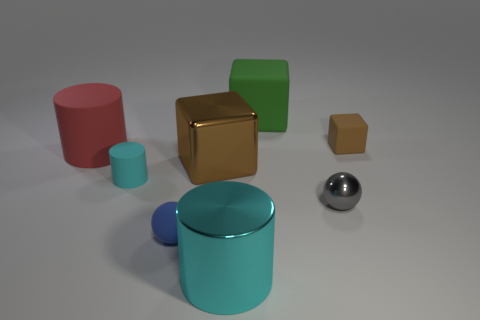Is the color of the thing that is in front of the tiny blue sphere the same as the cube that is behind the small brown cube?
Your answer should be very brief. No. What number of other objects are there of the same color as the metal sphere?
Provide a succinct answer. 0. What is the shape of the big rubber thing that is behind the small brown block?
Offer a terse response. Cube. Are there fewer small blue matte objects than large green metallic things?
Make the answer very short. No. Is the material of the ball to the right of the green thing the same as the blue object?
Make the answer very short. No. Are there any other things that are the same size as the red cylinder?
Offer a terse response. Yes. Are there any red matte cylinders on the left side of the big red matte object?
Your answer should be very brief. No. There is a large matte object that is in front of the brown thing to the right of the brown block in front of the brown rubber object; what color is it?
Give a very brief answer. Red. There is a brown metal object that is the same size as the green matte block; what is its shape?
Your response must be concise. Cube. Are there more tiny brown matte blocks than cubes?
Your answer should be very brief. No. 